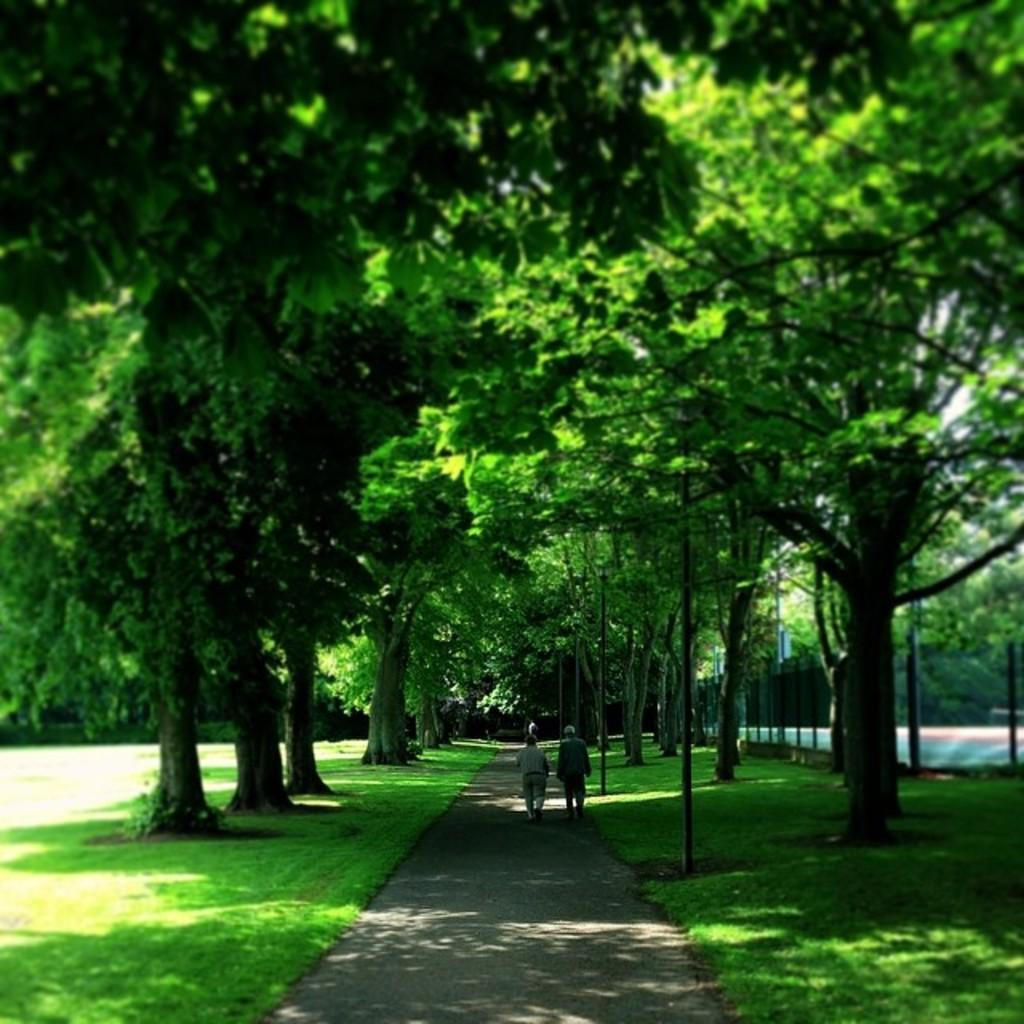What type of vegetation can be seen in the image? There are trees in the image. What is the ground covered with in the image? There is grass visible in the image. What are the people in the image doing? There are people on the road in the image. What else can be seen on the ground in the image? There are poles and other objects on the ground in the image. Who is the owner of the quicksand in the image? There is no quicksand present in the image, so it is not possible to determine the owner. What time of day is depicted in the image? The provided facts do not specify the time of day depicted in the image. 